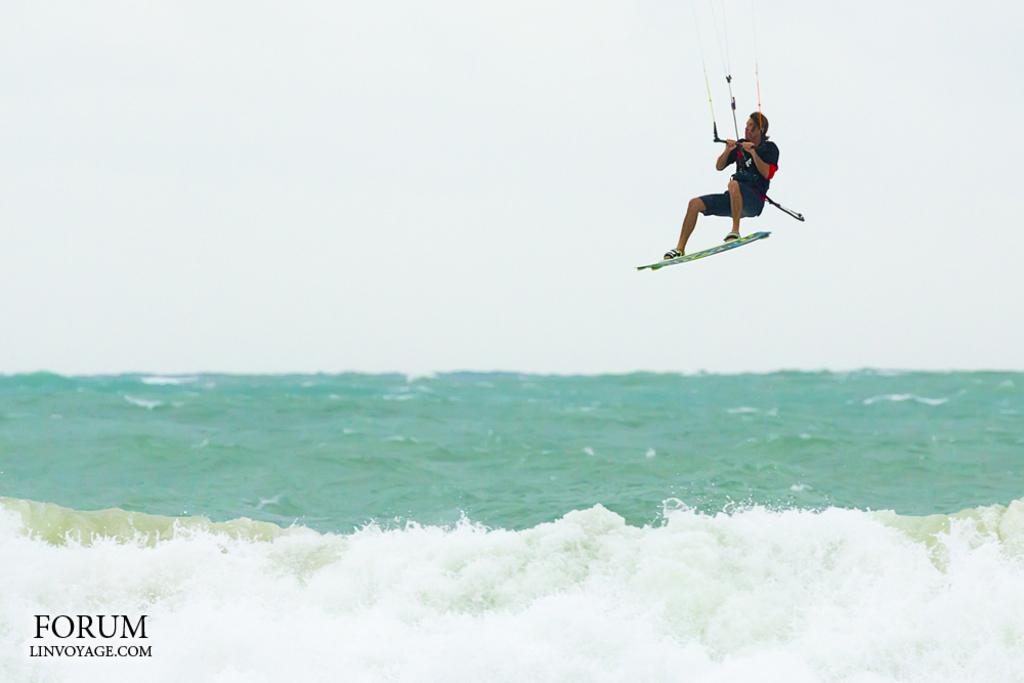What is present in the image? There is a person, a water board, water, the sky, and ropes visible in the image. Can you describe the person in the image? The person is wearing clothes. What is the water board used for? The water board is likely used for water-related activities, such as washing or irrigation. What can be seen in the sky in the image? The sky is visible in the image. What is the purpose of the ropes in the image? The ropes may be used for securing or tying objects, but their specific purpose is not clear from the image. Reasoning: Let's think step by step by step in order to produce the conversation. We start by identifying the main subjects and objects in the image based on the provided facts. We then formulate questions that focus on the characteristics and purpose of these subjects and objects, ensuring that each question can be answered definitively with the information given. We avoid yes/no questions and ensure that the language is simple and clear. Absurd Question/Answer: What type of wrench is being used by the person in the image? There is no wrench visible in the image. How many birds are perched on the water board in the image? There are no birds present in the image. What type of vest is the person wearing in the image? There is no vest visible in the image. How many birds are flying in the sky in the image? There are no birds present in the image. 